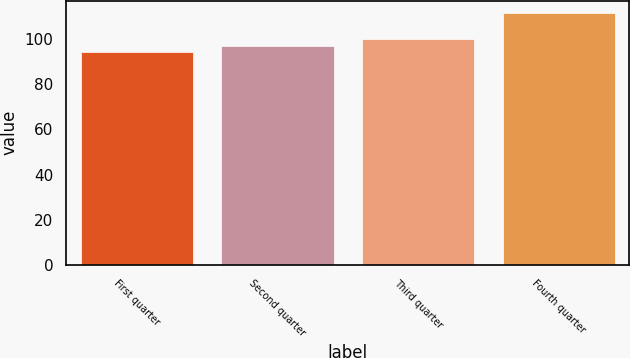<chart> <loc_0><loc_0><loc_500><loc_500><bar_chart><fcel>First quarter<fcel>Second quarter<fcel>Third quarter<fcel>Fourth quarter<nl><fcel>94.47<fcel>97.23<fcel>100<fcel>111.55<nl></chart> 